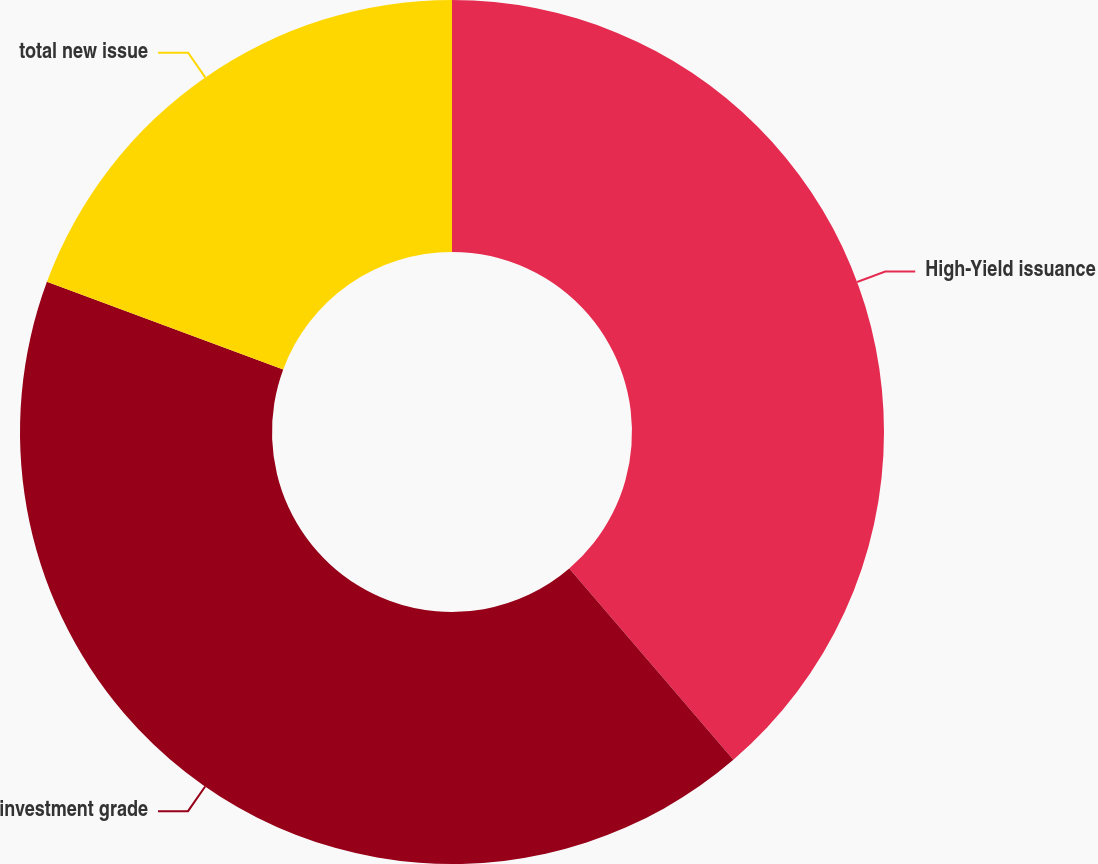Convert chart to OTSL. <chart><loc_0><loc_0><loc_500><loc_500><pie_chart><fcel>High-Yield issuance<fcel>investment grade<fcel>total new issue<nl><fcel>38.71%<fcel>41.94%<fcel>19.35%<nl></chart> 